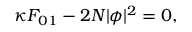Convert formula to latex. <formula><loc_0><loc_0><loc_500><loc_500>\kappa F _ { 0 1 } - 2 N | \phi | ^ { 2 } = 0 ,</formula> 